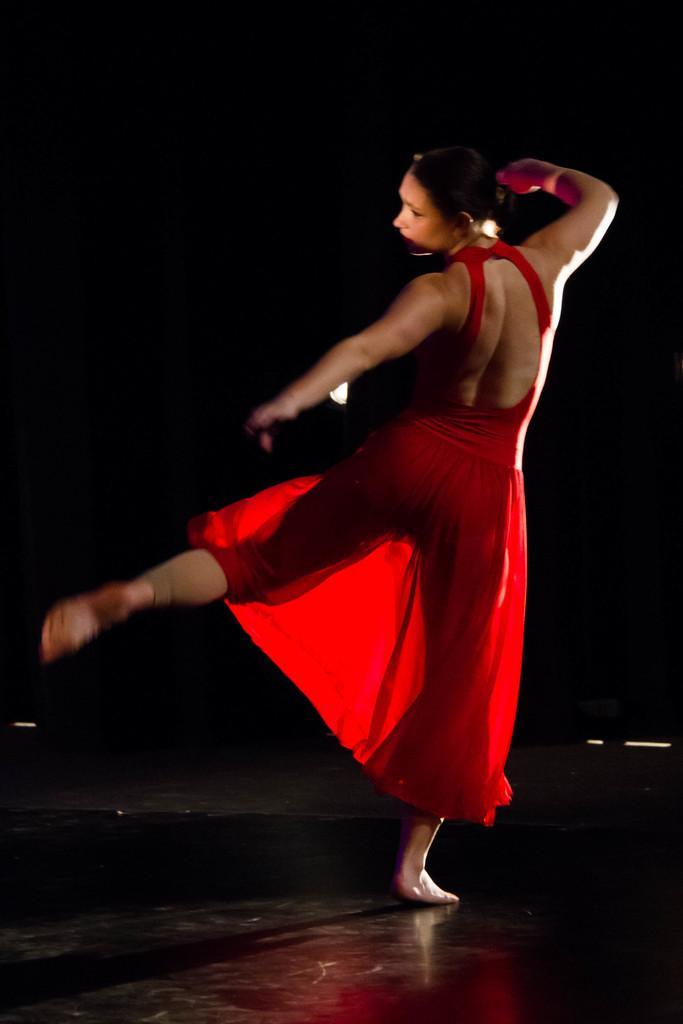Who is the main subject in the image? There is a lady in the image. What is the lady doing in the image? The lady is dancing. Can you describe the background of the image? The background of the image is dark. What type of structure can be seen in the background of the image? There is no structure visible in the background of the image; it is dark. Are there any trees present in the image? There are no trees visible in the image; it only features a lady dancing against a dark background. 